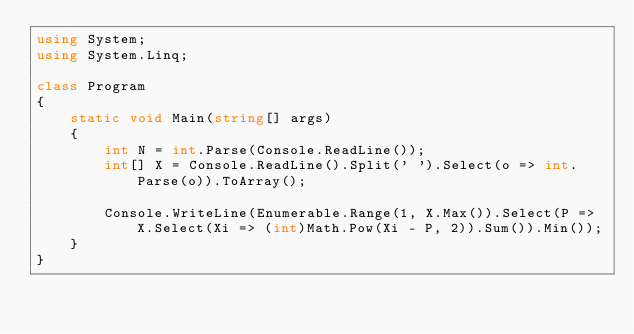Convert code to text. <code><loc_0><loc_0><loc_500><loc_500><_C#_>using System;
using System.Linq;

class Program
{
    static void Main(string[] args)
    {
        int N = int.Parse(Console.ReadLine());
        int[] X = Console.ReadLine().Split(' ').Select(o => int.Parse(o)).ToArray();

        Console.WriteLine(Enumerable.Range(1, X.Max()).Select(P => X.Select(Xi => (int)Math.Pow(Xi - P, 2)).Sum()).Min());
    }
}</code> 